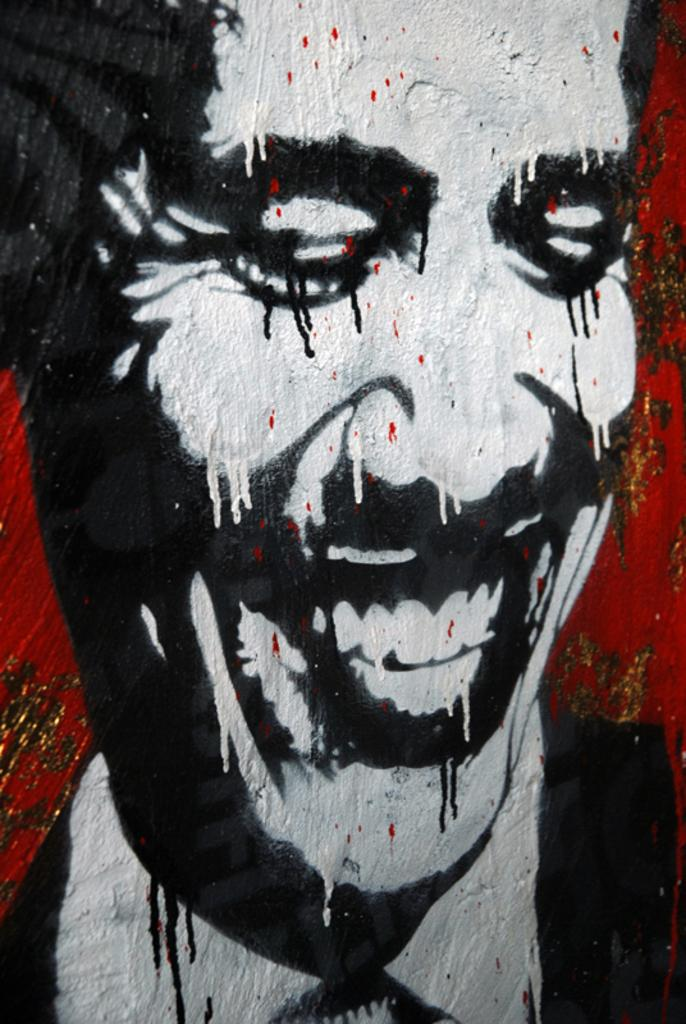What is depicted on the wall in the image? There is a person's painting on the wall in the image. Can you describe the painting in more detail? Unfortunately, the provided facts do not give any additional details about the painting. Is there any other artwork or decoration visible in the image? The provided facts do not mention any other artwork or decoration in the image. What type of doctor is attending to the person in the painting? There is no person depicted in the painting, nor is there any indication of a doctor or medical situation in the image. 